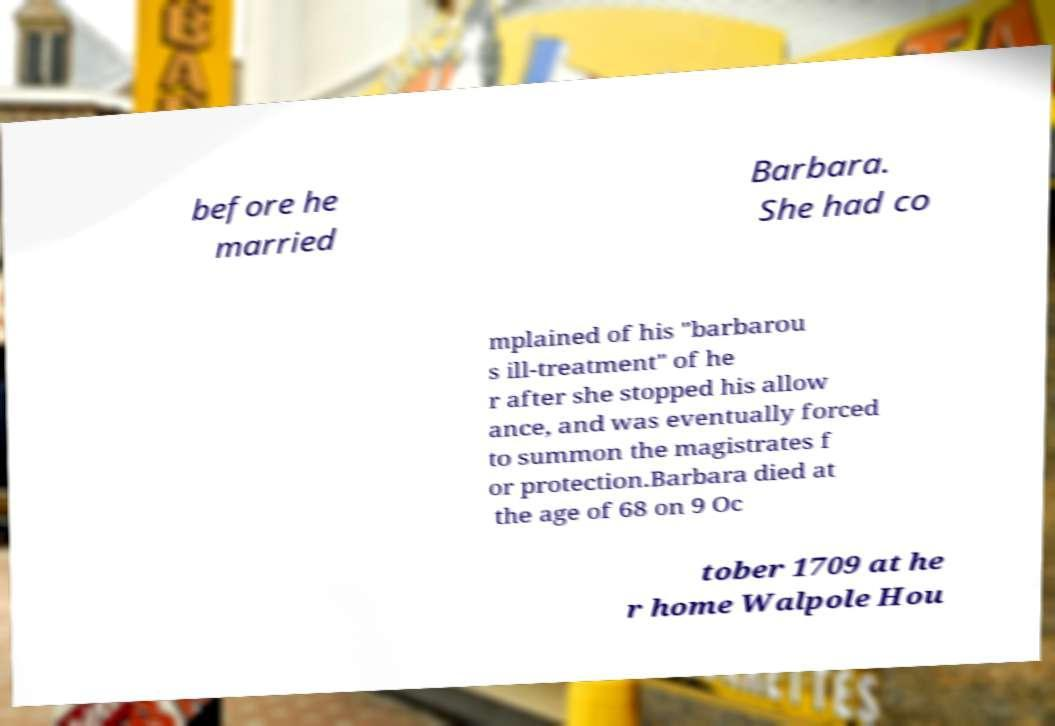What messages or text are displayed in this image? I need them in a readable, typed format. before he married Barbara. She had co mplained of his "barbarou s ill-treatment" of he r after she stopped his allow ance, and was eventually forced to summon the magistrates f or protection.Barbara died at the age of 68 on 9 Oc tober 1709 at he r home Walpole Hou 